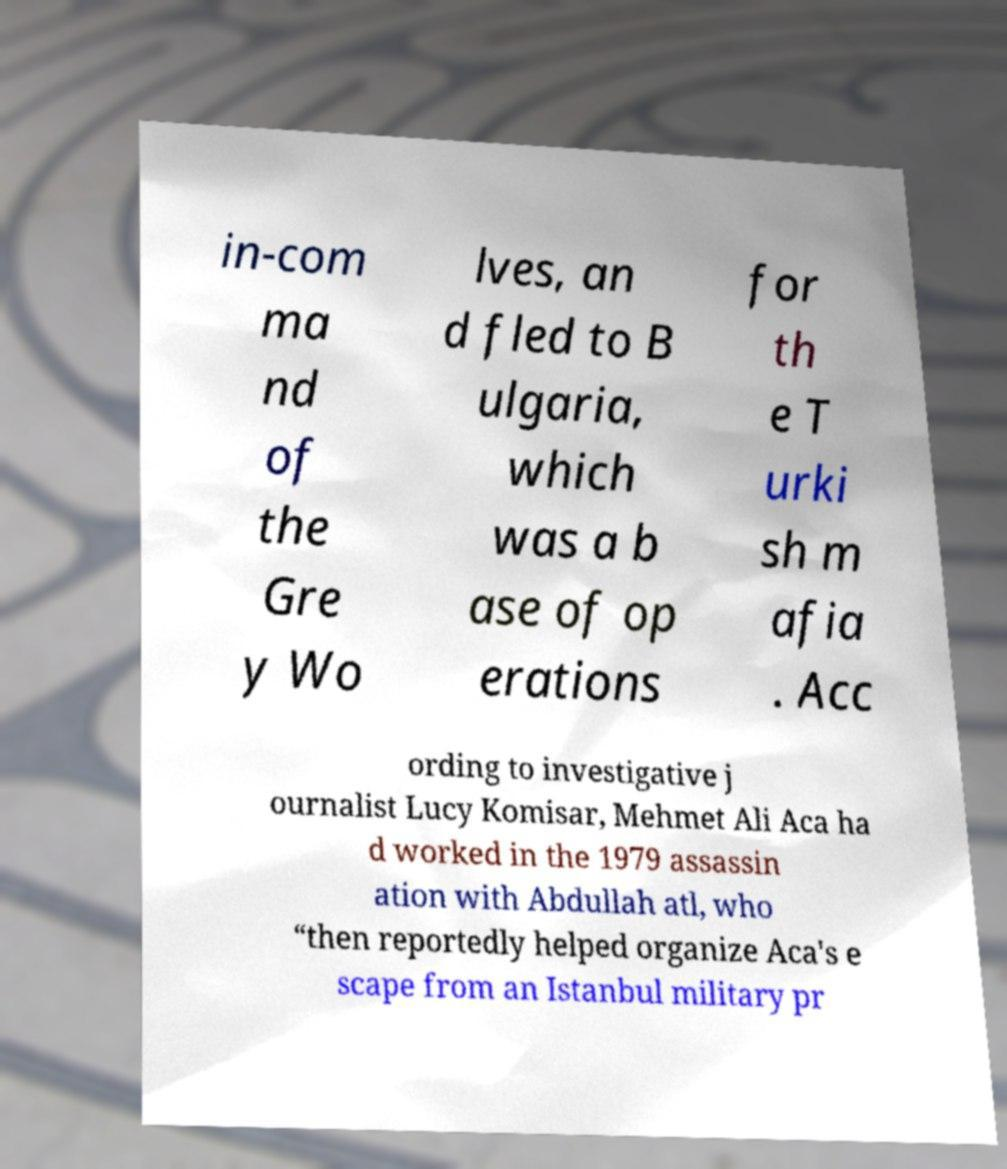Please identify and transcribe the text found in this image. in-com ma nd of the Gre y Wo lves, an d fled to B ulgaria, which was a b ase of op erations for th e T urki sh m afia . Acc ording to investigative j ournalist Lucy Komisar, Mehmet Ali Aca ha d worked in the 1979 assassin ation with Abdullah atl, who “then reportedly helped organize Aca's e scape from an Istanbul military pr 